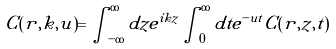<formula> <loc_0><loc_0><loc_500><loc_500>C ( r , k , u ) = \int _ { - \infty } ^ { \infty } d z e ^ { i k z } \int _ { 0 } ^ { \infty } d t e ^ { - u t } C ( r , z , t )</formula> 